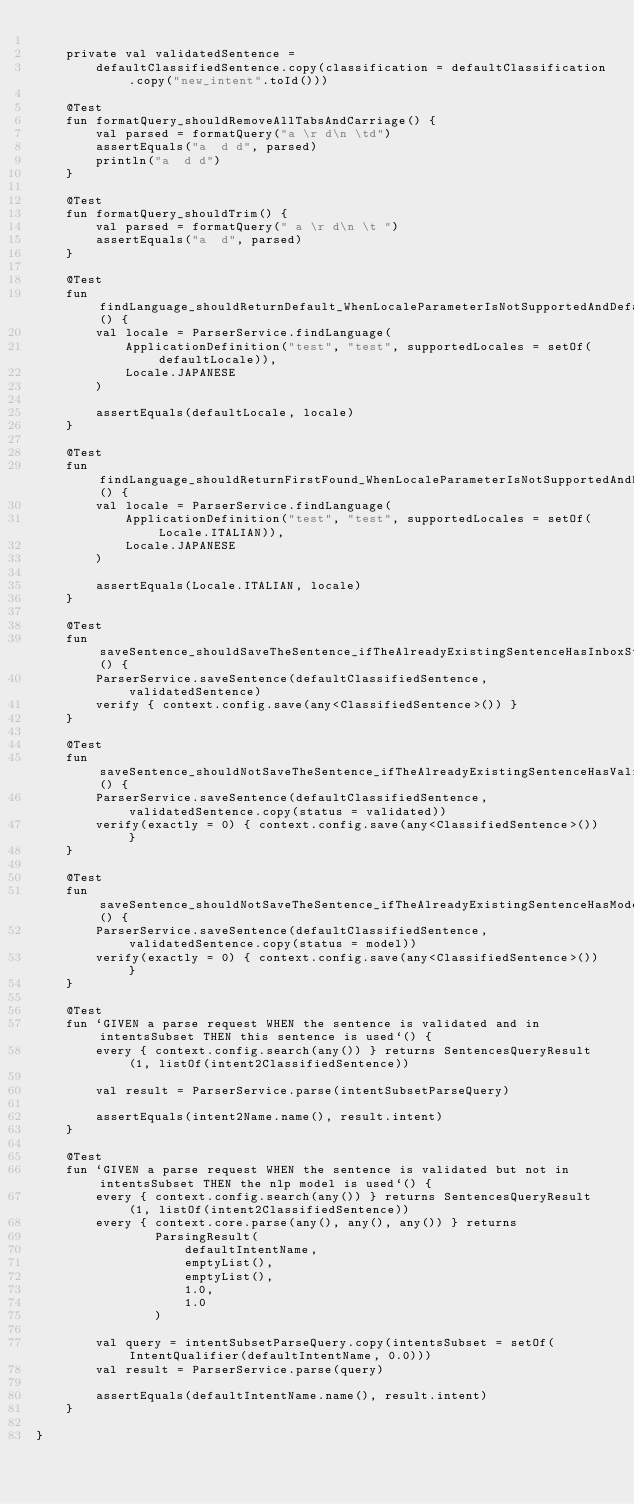Convert code to text. <code><loc_0><loc_0><loc_500><loc_500><_Kotlin_>
    private val validatedSentence =
        defaultClassifiedSentence.copy(classification = defaultClassification.copy("new_intent".toId()))

    @Test
    fun formatQuery_shouldRemoveAllTabsAndCarriage() {
        val parsed = formatQuery("a \r d\n \td")
        assertEquals("a  d d", parsed)
        println("a  d d")
    }

    @Test
    fun formatQuery_shouldTrim() {
        val parsed = formatQuery(" a \r d\n \t ")
        assertEquals("a  d", parsed)
    }

    @Test
    fun findLanguage_shouldReturnDefault_WhenLocaleParameterIsNotSupportedAndDefaultIsSupported() {
        val locale = ParserService.findLanguage(
            ApplicationDefinition("test", "test", supportedLocales = setOf(defaultLocale)),
            Locale.JAPANESE
        )

        assertEquals(defaultLocale, locale)
    }

    @Test
    fun findLanguage_shouldReturnFirstFound_WhenLocaleParameterIsNotSupportedAndDefaultIsNotSupported() {
        val locale = ParserService.findLanguage(
            ApplicationDefinition("test", "test", supportedLocales = setOf(Locale.ITALIAN)),
            Locale.JAPANESE
        )

        assertEquals(Locale.ITALIAN, locale)
    }

    @Test
    fun saveSentence_shouldSaveTheSentence_ifTheAlreadyExistingSentenceHasInboxStatusAndNotSameContent() {
        ParserService.saveSentence(defaultClassifiedSentence, validatedSentence)
        verify { context.config.save(any<ClassifiedSentence>()) }
    }

    @Test
    fun saveSentence_shouldNotSaveTheSentence_ifTheAlreadyExistingSentenceHasValidatedStatus() {
        ParserService.saveSentence(defaultClassifiedSentence, validatedSentence.copy(status = validated))
        verify(exactly = 0) { context.config.save(any<ClassifiedSentence>()) }
    }

    @Test
    fun saveSentence_shouldNotSaveTheSentence_ifTheAlreadyExistingSentenceHasModelStatus() {
        ParserService.saveSentence(defaultClassifiedSentence, validatedSentence.copy(status = model))
        verify(exactly = 0) { context.config.save(any<ClassifiedSentence>()) }
    }

    @Test
    fun `GIVEN a parse request WHEN the sentence is validated and in intentsSubset THEN this sentence is used`() {
        every { context.config.search(any()) } returns SentencesQueryResult(1, listOf(intent2ClassifiedSentence))

        val result = ParserService.parse(intentSubsetParseQuery)

        assertEquals(intent2Name.name(), result.intent)
    }

    @Test
    fun `GIVEN a parse request WHEN the sentence is validated but not in intentsSubset THEN the nlp model is used`() {
        every { context.config.search(any()) } returns SentencesQueryResult(1, listOf(intent2ClassifiedSentence))
        every { context.core.parse(any(), any(), any()) } returns
                ParsingResult(
                    defaultIntentName,
                    emptyList(),
                    emptyList(),
                    1.0,
                    1.0
                )

        val query = intentSubsetParseQuery.copy(intentsSubset = setOf(IntentQualifier(defaultIntentName, 0.0)))
        val result = ParserService.parse(query)

        assertEquals(defaultIntentName.name(), result.intent)
    }

}</code> 